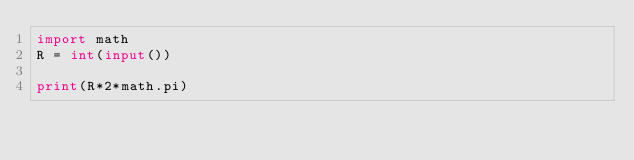<code> <loc_0><loc_0><loc_500><loc_500><_Python_>import math
R = int(input())

print(R*2*math.pi)</code> 